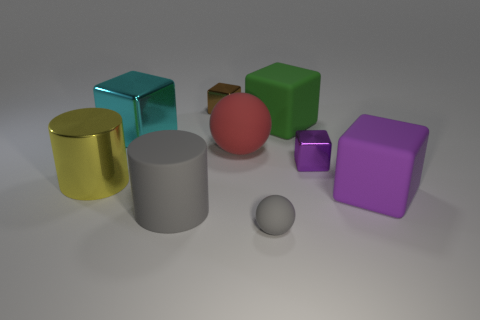Subtract 1 blocks. How many blocks are left? 4 Subtract all red blocks. Subtract all cyan spheres. How many blocks are left? 5 Add 1 gray matte cylinders. How many objects exist? 10 Subtract all cylinders. How many objects are left? 7 Add 4 large gray cylinders. How many large gray cylinders are left? 5 Add 3 large yellow rubber cylinders. How many large yellow rubber cylinders exist? 3 Subtract 0 blue cylinders. How many objects are left? 9 Subtract all red matte spheres. Subtract all matte objects. How many objects are left? 3 